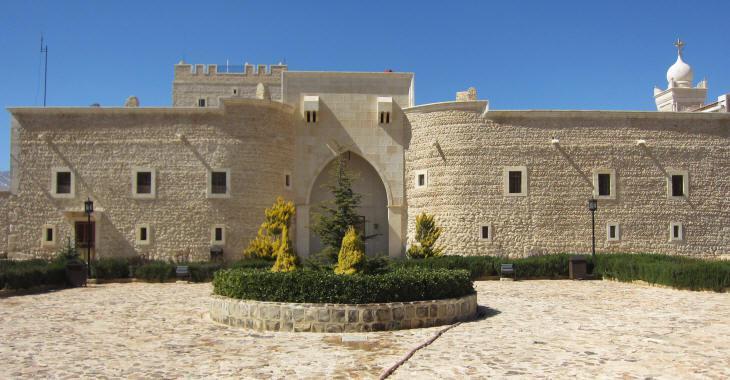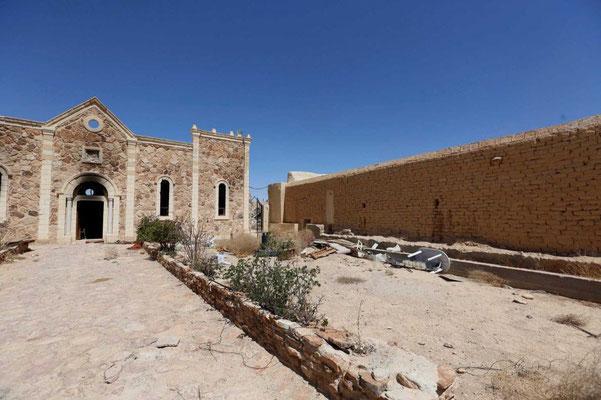The first image is the image on the left, the second image is the image on the right. Assess this claim about the two images: "A set of stairs lead to an arch in at least one image.". Correct or not? Answer yes or no. No. 